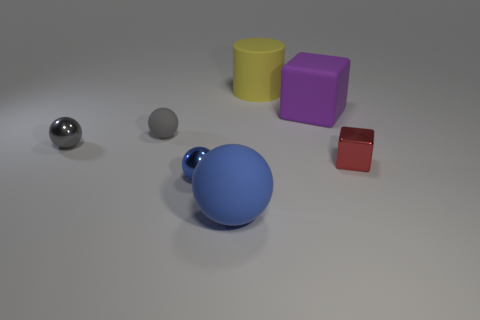Add 3 cubes. How many objects exist? 10 Subtract all brown balls. Subtract all green cylinders. How many balls are left? 4 Subtract all spheres. How many objects are left? 3 Subtract 0 cyan cylinders. How many objects are left? 7 Subtract all tiny gray cubes. Subtract all big yellow cylinders. How many objects are left? 6 Add 1 yellow objects. How many yellow objects are left? 2 Add 4 brown things. How many brown things exist? 4 